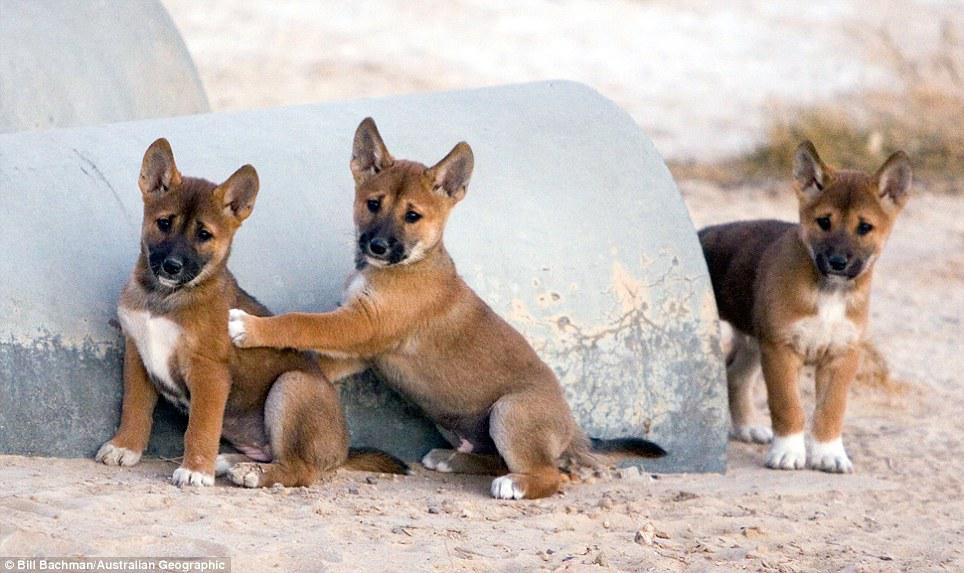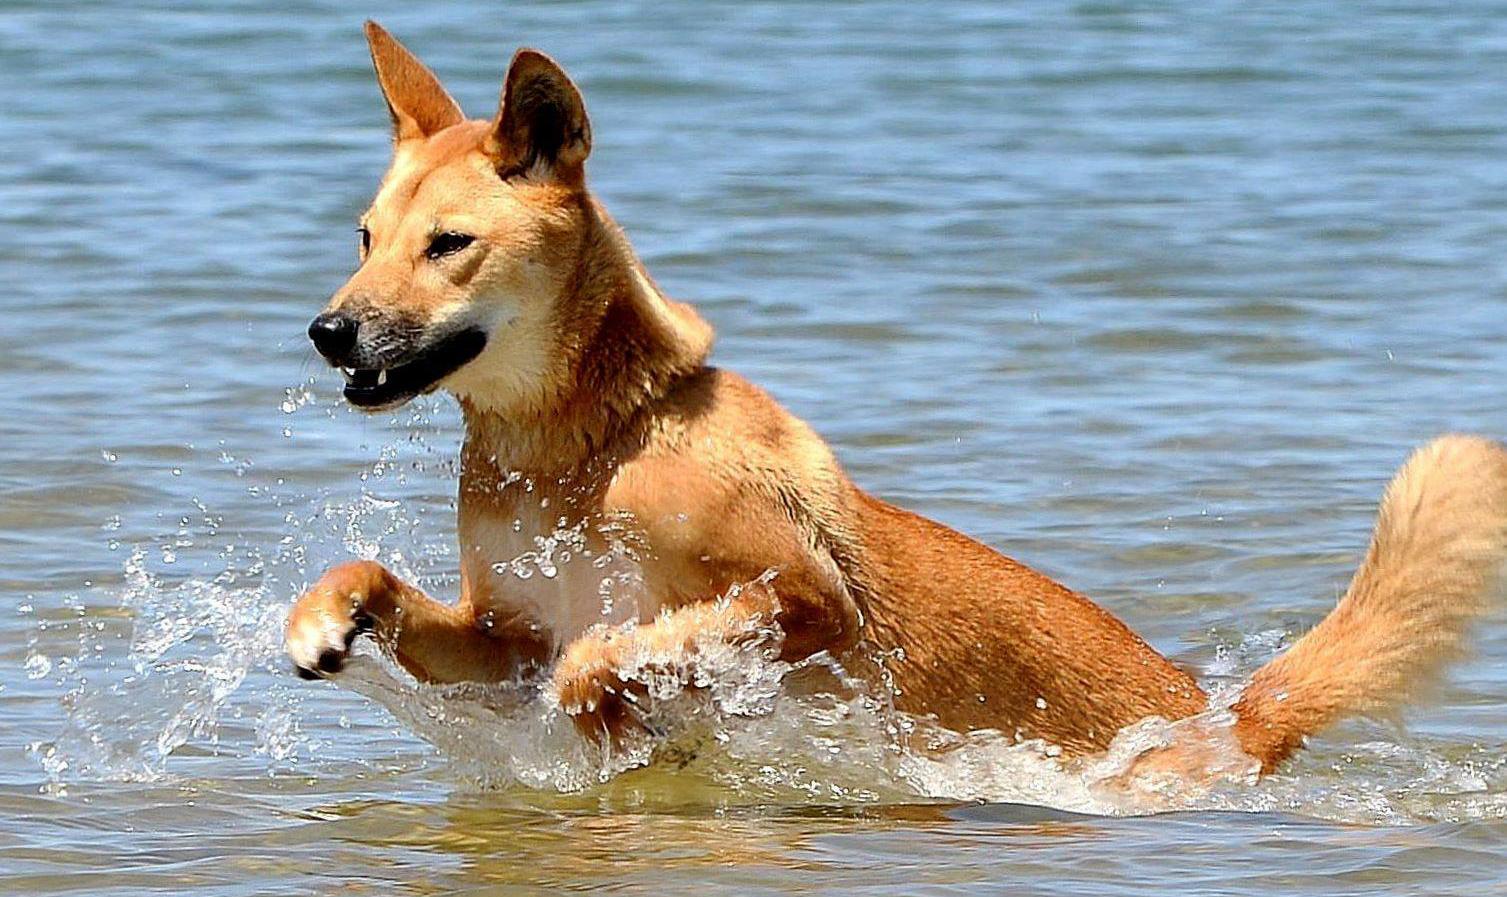The first image is the image on the left, the second image is the image on the right. Analyze the images presented: Is the assertion "At least one dog is in water, surrounded by water." valid? Answer yes or no. Yes. 